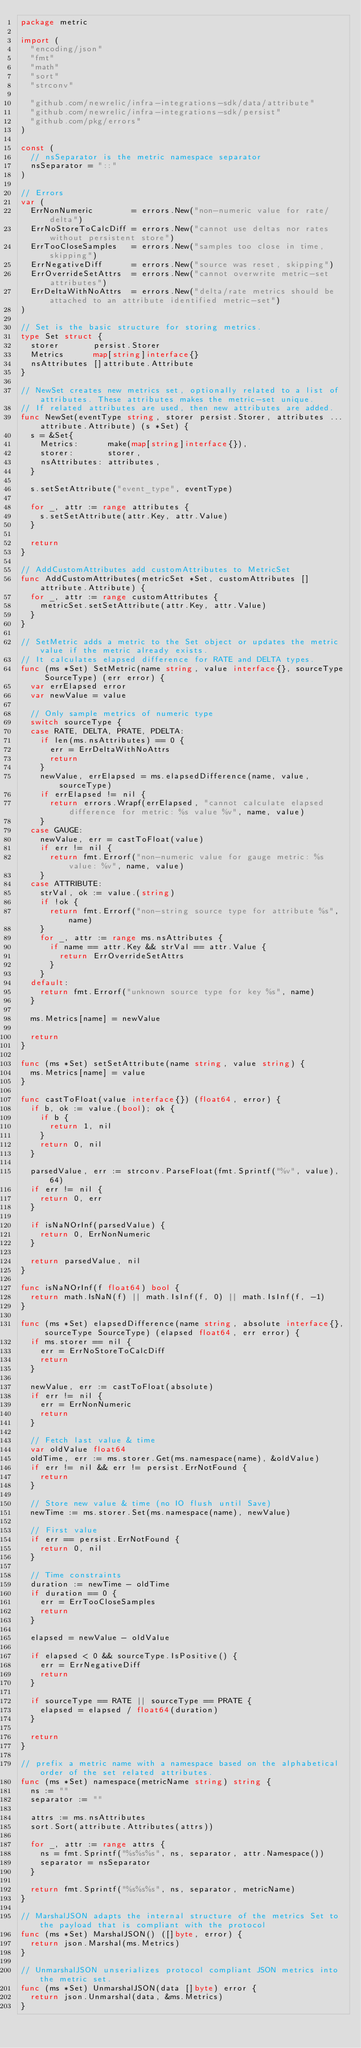<code> <loc_0><loc_0><loc_500><loc_500><_Go_>package metric

import (
	"encoding/json"
	"fmt"
	"math"
	"sort"
	"strconv"

	"github.com/newrelic/infra-integrations-sdk/data/attribute"
	"github.com/newrelic/infra-integrations-sdk/persist"
	"github.com/pkg/errors"
)

const (
	// nsSeparator is the metric namespace separator
	nsSeparator = "::"
)

// Errors
var (
	ErrNonNumeric        = errors.New("non-numeric value for rate/delta")
	ErrNoStoreToCalcDiff = errors.New("cannot use deltas nor rates without persistent store")
	ErrTooCloseSamples   = errors.New("samples too close in time, skipping")
	ErrNegativeDiff      = errors.New("source was reset, skipping")
	ErrOverrideSetAttrs  = errors.New("cannot overwrite metric-set attributes")
	ErrDeltaWithNoAttrs  = errors.New("delta/rate metrics should be attached to an attribute identified metric-set")
)

// Set is the basic structure for storing metrics.
type Set struct {
	storer       persist.Storer
	Metrics      map[string]interface{}
	nsAttributes []attribute.Attribute
}

// NewSet creates new metrics set, optionally related to a list of attributes. These attributes makes the metric-set unique.
// If related attributes are used, then new attributes are added.
func NewSet(eventType string, storer persist.Storer, attributes ...attribute.Attribute) (s *Set) {
	s = &Set{
		Metrics:      make(map[string]interface{}),
		storer:       storer,
		nsAttributes: attributes,
	}

	s.setSetAttribute("event_type", eventType)

	for _, attr := range attributes {
		s.setSetAttribute(attr.Key, attr.Value)
	}

	return
}

// AddCustomAttributes add customAttributes to MetricSet
func AddCustomAttributes(metricSet *Set, customAttributes []attribute.Attribute) {
	for _, attr := range customAttributes {
		metricSet.setSetAttribute(attr.Key, attr.Value)
	}
}

// SetMetric adds a metric to the Set object or updates the metric value if the metric already exists.
// It calculates elapsed difference for RATE and DELTA types.
func (ms *Set) SetMetric(name string, value interface{}, sourceType SourceType) (err error) {
	var errElapsed error
	var newValue = value

	// Only sample metrics of numeric type
	switch sourceType {
	case RATE, DELTA, PRATE, PDELTA:
		if len(ms.nsAttributes) == 0 {
			err = ErrDeltaWithNoAttrs
			return
		}
		newValue, errElapsed = ms.elapsedDifference(name, value, sourceType)
		if errElapsed != nil {
			return errors.Wrapf(errElapsed, "cannot calculate elapsed difference for metric: %s value %v", name, value)
		}
	case GAUGE:
		newValue, err = castToFloat(value)
		if err != nil {
			return fmt.Errorf("non-numeric value for gauge metric: %s value: %v", name, value)
		}
	case ATTRIBUTE:
		strVal, ok := value.(string)
		if !ok {
			return fmt.Errorf("non-string source type for attribute %s", name)
		}
		for _, attr := range ms.nsAttributes {
			if name == attr.Key && strVal == attr.Value {
				return ErrOverrideSetAttrs
			}
		}
	default:
		return fmt.Errorf("unknown source type for key %s", name)
	}

	ms.Metrics[name] = newValue

	return
}

func (ms *Set) setSetAttribute(name string, value string) {
	ms.Metrics[name] = value
}

func castToFloat(value interface{}) (float64, error) {
	if b, ok := value.(bool); ok {
		if b {
			return 1, nil
		}
		return 0, nil
	}

	parsedValue, err := strconv.ParseFloat(fmt.Sprintf("%v", value), 64)
	if err != nil {
		return 0, err
	}

	if isNaNOrInf(parsedValue) {
		return 0, ErrNonNumeric
	}

	return parsedValue, nil
}

func isNaNOrInf(f float64) bool {
	return math.IsNaN(f) || math.IsInf(f, 0) || math.IsInf(f, -1)
}

func (ms *Set) elapsedDifference(name string, absolute interface{}, sourceType SourceType) (elapsed float64, err error) {
	if ms.storer == nil {
		err = ErrNoStoreToCalcDiff
		return
	}

	newValue, err := castToFloat(absolute)
	if err != nil {
		err = ErrNonNumeric
		return
	}

	// Fetch last value & time
	var oldValue float64
	oldTime, err := ms.storer.Get(ms.namespace(name), &oldValue)
	if err != nil && err != persist.ErrNotFound {
		return
	}

	// Store new value & time (no IO flush until Save)
	newTime := ms.storer.Set(ms.namespace(name), newValue)

	// First value
	if err == persist.ErrNotFound {
		return 0, nil
	}

	// Time constraints
	duration := newTime - oldTime
	if duration == 0 {
		err = ErrTooCloseSamples
		return
	}

	elapsed = newValue - oldValue

	if elapsed < 0 && sourceType.IsPositive() {
		err = ErrNegativeDiff
		return
	}

	if sourceType == RATE || sourceType == PRATE {
		elapsed = elapsed / float64(duration)
	}

	return
}

// prefix a metric name with a namespace based on the alphabetical order of the set related attributes.
func (ms *Set) namespace(metricName string) string {
	ns := ""
	separator := ""

	attrs := ms.nsAttributes
	sort.Sort(attribute.Attributes(attrs))

	for _, attr := range attrs {
		ns = fmt.Sprintf("%s%s%s", ns, separator, attr.Namespace())
		separator = nsSeparator
	}

	return fmt.Sprintf("%s%s%s", ns, separator, metricName)
}

// MarshalJSON adapts the internal structure of the metrics Set to the payload that is compliant with the protocol
func (ms *Set) MarshalJSON() ([]byte, error) {
	return json.Marshal(ms.Metrics)
}

// UnmarshalJSON unserializes protocol compliant JSON metrics into the metric set.
func (ms *Set) UnmarshalJSON(data []byte) error {
	return json.Unmarshal(data, &ms.Metrics)
}
</code> 